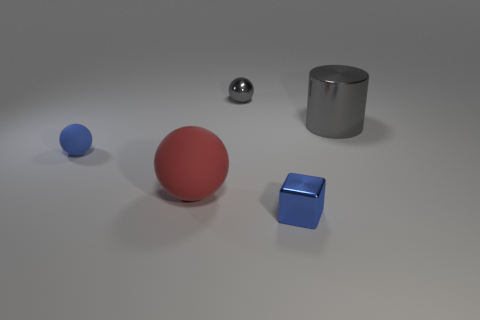Subtract all small balls. How many balls are left? 1 Add 5 tiny yellow shiny balls. How many objects exist? 10 Subtract all purple spheres. How many purple cylinders are left? 0 Subtract all brown metallic cubes. Subtract all big shiny objects. How many objects are left? 4 Add 1 gray shiny objects. How many gray shiny objects are left? 3 Add 5 large green metallic things. How many large green metallic things exist? 5 Subtract 0 yellow cubes. How many objects are left? 5 Subtract all cubes. How many objects are left? 4 Subtract all red balls. Subtract all blue cylinders. How many balls are left? 2 